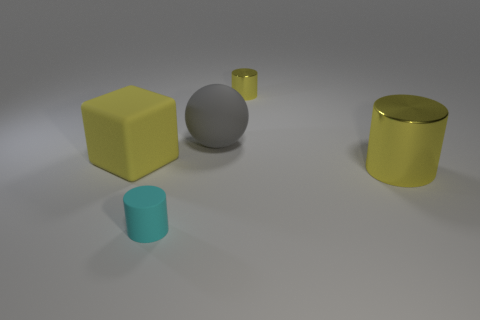How many yellow things are either shiny spheres or large things?
Give a very brief answer. 2. Is the color of the big object that is in front of the large rubber cube the same as the matte block?
Give a very brief answer. Yes. Is the material of the big gray sphere the same as the small cyan thing?
Provide a succinct answer. Yes. Are there the same number of yellow cylinders that are behind the yellow rubber block and tiny yellow cylinders that are in front of the big metal cylinder?
Provide a short and direct response. No. There is another small cyan object that is the same shape as the small metallic thing; what material is it?
Your response must be concise. Rubber. There is a small matte thing that is to the left of the big thing on the right side of the yellow metal cylinder that is behind the big gray ball; what shape is it?
Offer a terse response. Cylinder. Is the number of large yellow cylinders that are behind the large rubber ball greater than the number of small blue objects?
Offer a very short reply. No. There is a big thing right of the tiny metallic thing; is it the same shape as the cyan thing?
Your response must be concise. Yes. There is a small cylinder in front of the gray sphere; what material is it?
Give a very brief answer. Rubber. How many small cyan rubber objects have the same shape as the large gray object?
Offer a terse response. 0. 